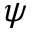Convert formula to latex. <formula><loc_0><loc_0><loc_500><loc_500>\psi</formula> 